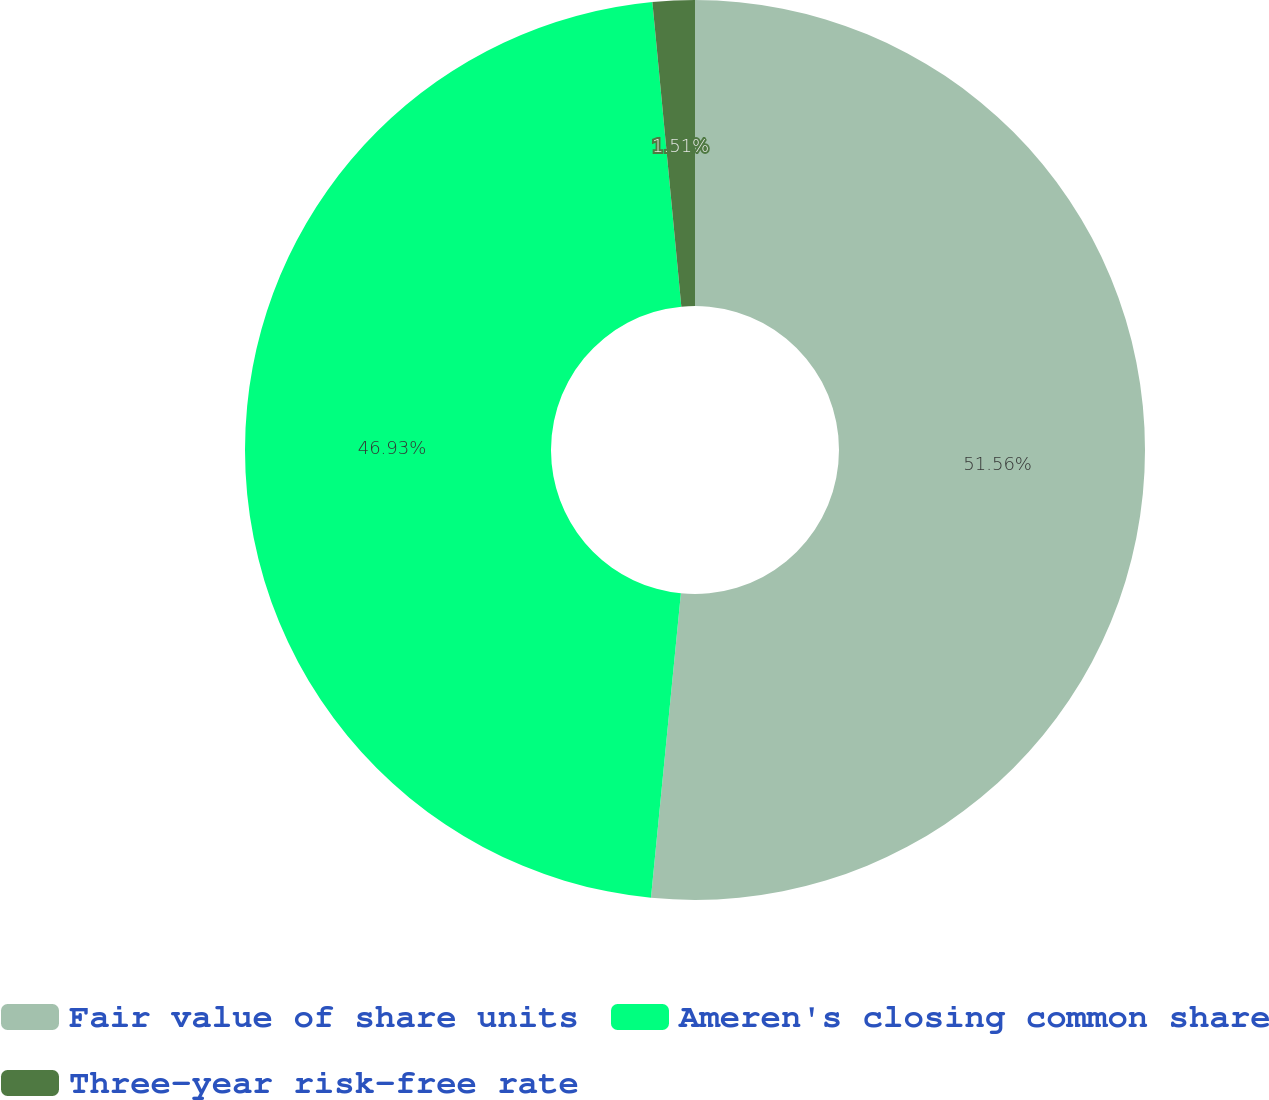<chart> <loc_0><loc_0><loc_500><loc_500><pie_chart><fcel>Fair value of share units<fcel>Ameren's closing common share<fcel>Three-year risk-free rate<nl><fcel>51.56%<fcel>46.93%<fcel>1.51%<nl></chart> 